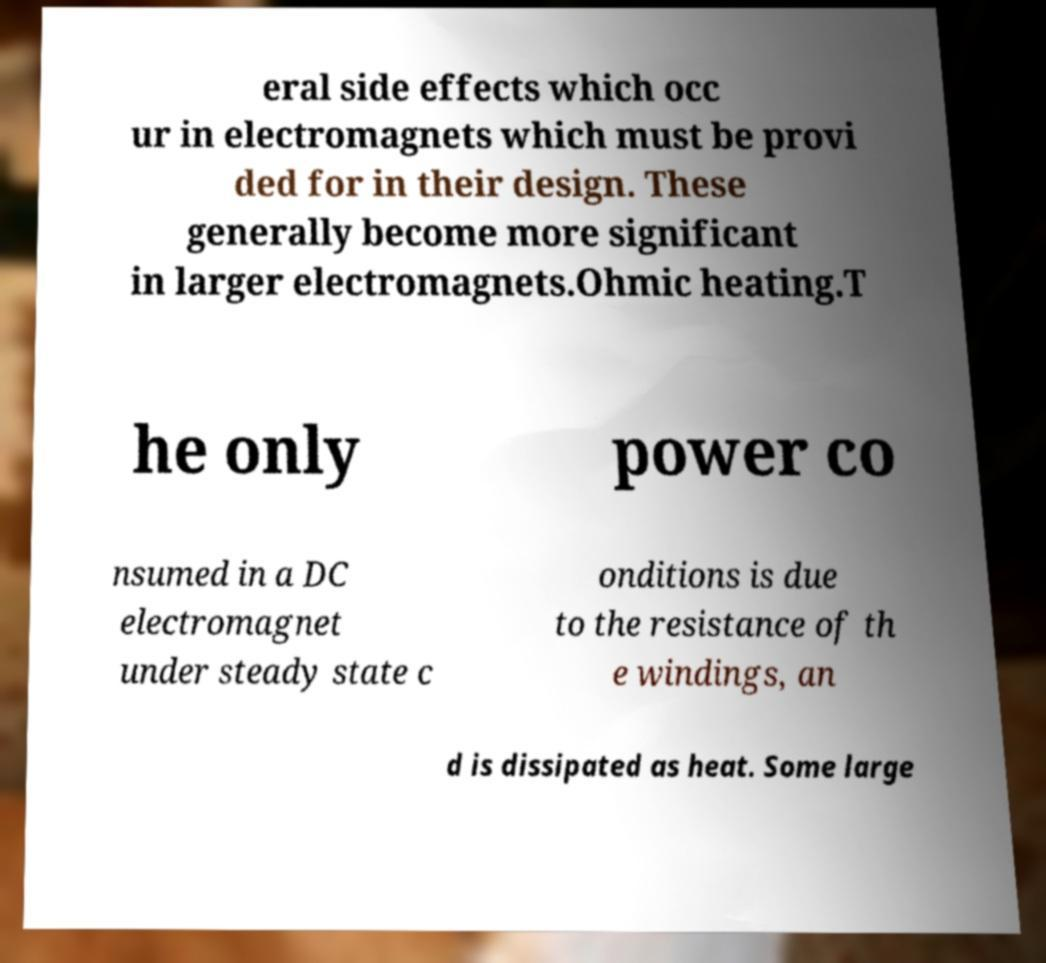What messages or text are displayed in this image? I need them in a readable, typed format. eral side effects which occ ur in electromagnets which must be provi ded for in their design. These generally become more significant in larger electromagnets.Ohmic heating.T he only power co nsumed in a DC electromagnet under steady state c onditions is due to the resistance of th e windings, an d is dissipated as heat. Some large 